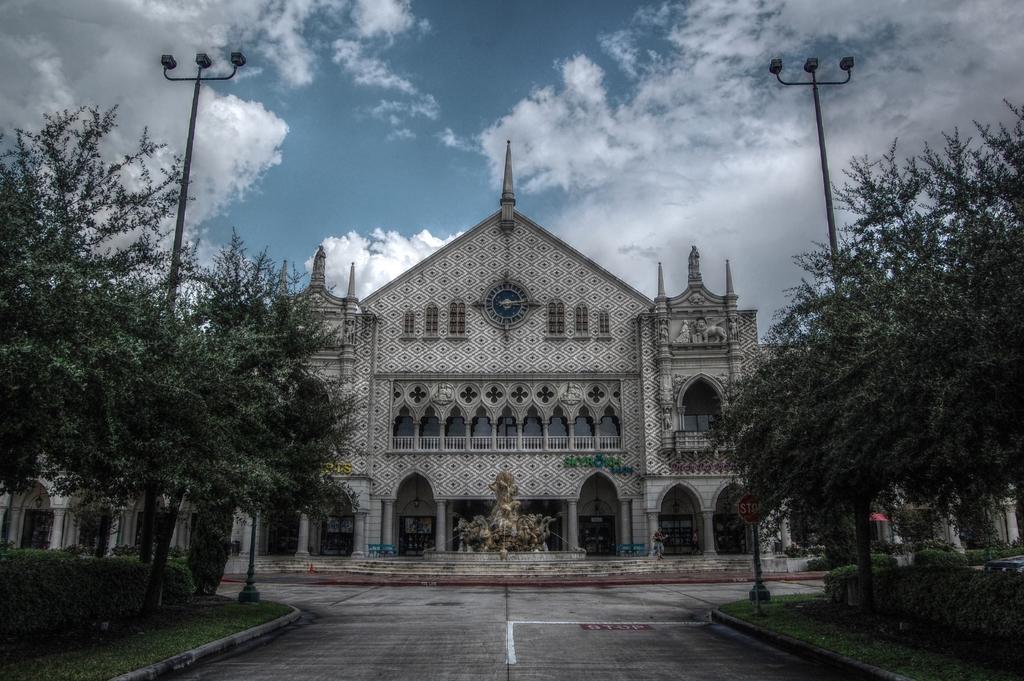Please provide a concise description of this image. In this image we can see the building and also the statues, light poles, trees, grass and also the stop sign pole. We can also see the road. In the background we can see the sky with the clouds. 